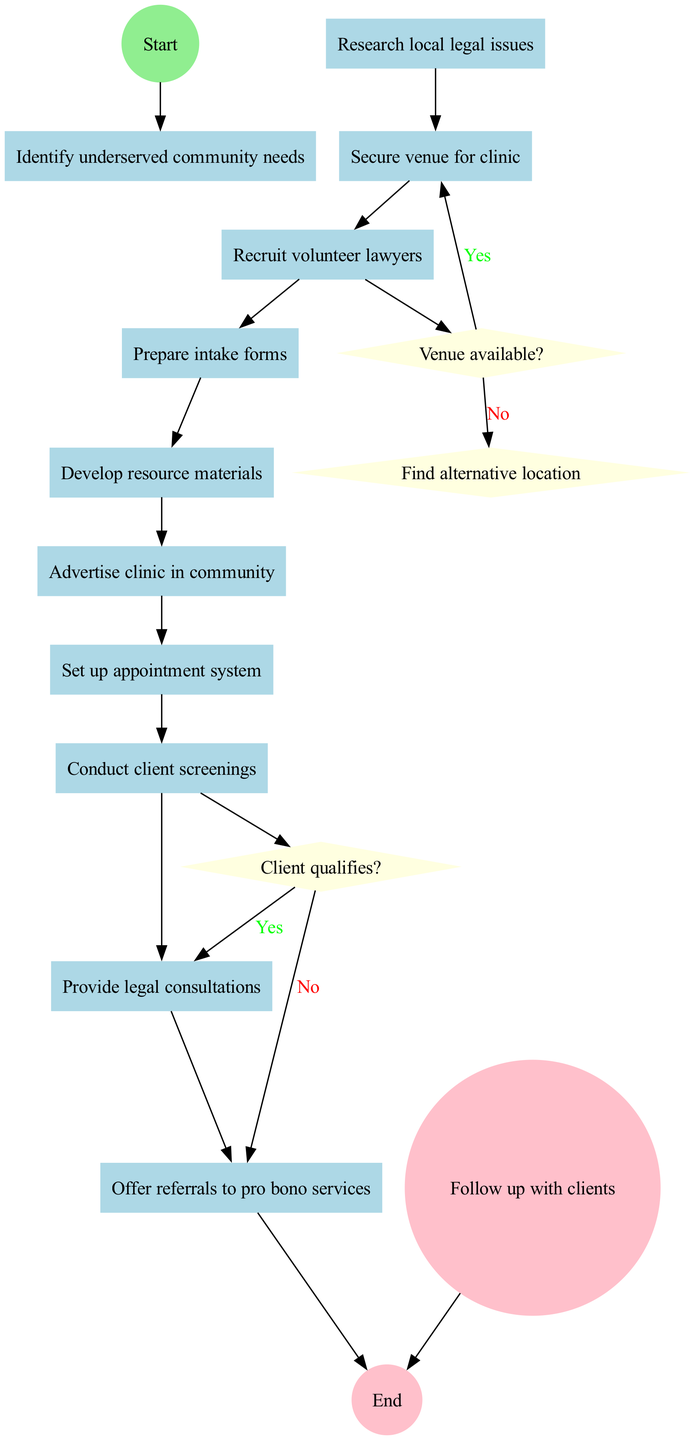What is the start node of the diagram? The diagram indicates that the first step or start node is "Identify underserved community needs."
Answer: Identify underserved community needs How many activities are listed in the diagram? By counting the activities in the diagram, we identify there are ten specific activities outlined for organizing the clinic.
Answer: 10 What happens if the venue is not available? According to the diagram, if the venue is not available, the next step is to "Find alternative location," which is indicated as the outcome of the decision condition for venue availability.
Answer: Find alternative location What activity follows after "Conduct client screenings"? The diagram shows that after "Conduct client screenings," the next activity is to "Provide legal consultations" based on the flow of activities arranged sequentially.
Answer: Provide legal consultations Which decision checks if a client qualifies? The diagram depicts a decision node labeled "Client qualifies?" that determines whether to provide legal consultations or refer clients to pro bono services.
Answer: Client qualifies? How many decision nodes are present in the diagram? By examining the diagram, it can be noted that there are two decision nodes present, each defining a crucial point in the process regarding venue availability and client qualification.
Answer: 2 What color represents the end node? The end node has been designated with the color pink as specified in the color attributes of the diagram.
Answer: Pink What is the last activity performed before following up with clients? The last specified activity before reaching the end of the process is "Offer referrals to pro bono services," according to the order of activities leading to the final follow-up step.
Answer: Offer referrals to pro bono services What is the condition for proceeding to "Secure venue for clinic"? The diagram specifies that the condition to proceed involves checking whether the "Venue available?" as it directs the flow towards securing the venue if the answer is affirmative.
Answer: Venue available? 